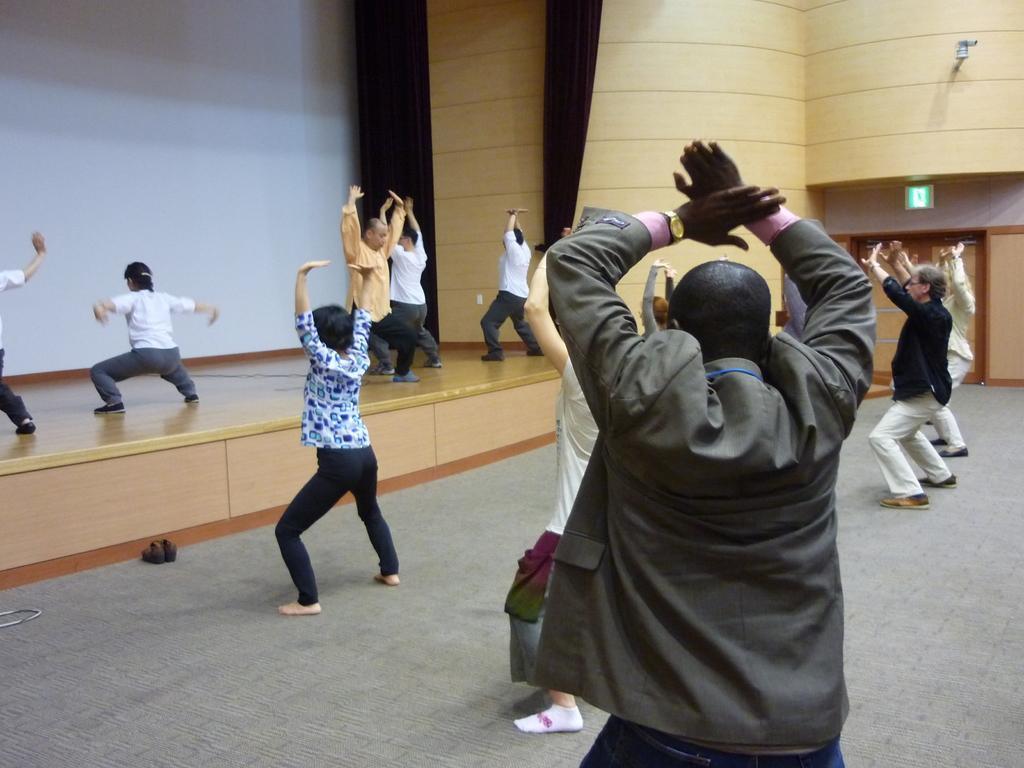Describe this image in one or two sentences. In the image there are few persons doing exercise on the floor and some are on the stage, at the back there is wall with cc camera on the right side corner, this is clicked inside a auditorium. 